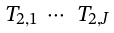Convert formula to latex. <formula><loc_0><loc_0><loc_500><loc_500>\begin{smallmatrix} T _ { 2 , 1 } & \cdots & T _ { 2 , J } \end{smallmatrix}</formula> 